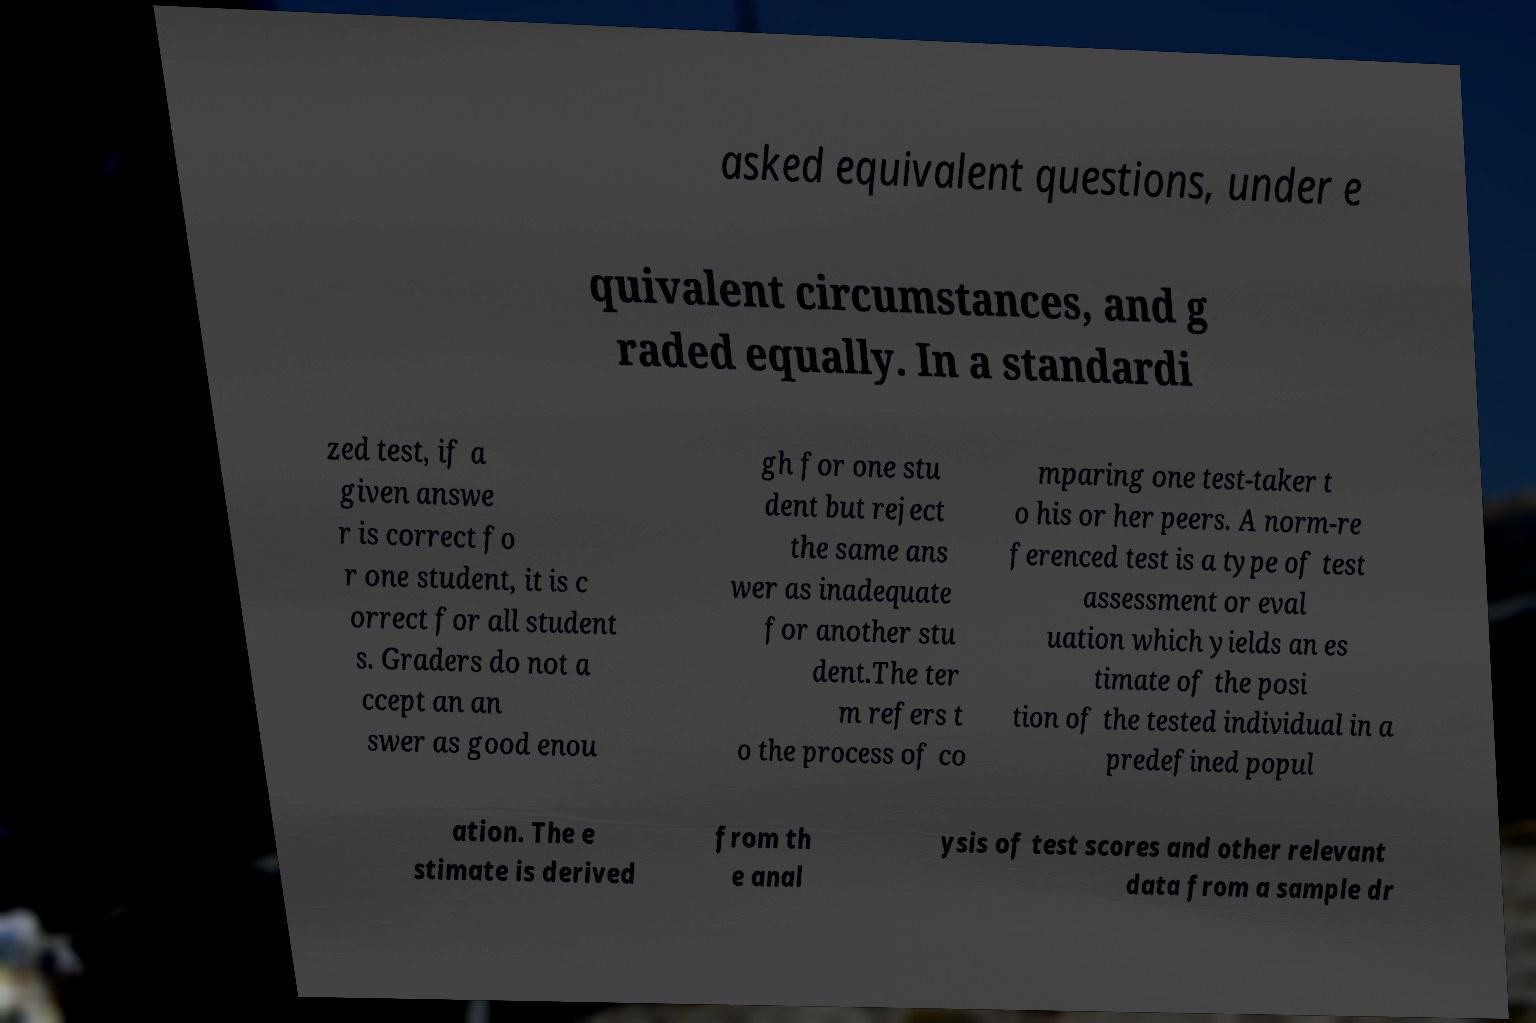Can you accurately transcribe the text from the provided image for me? asked equivalent questions, under e quivalent circumstances, and g raded equally. In a standardi zed test, if a given answe r is correct fo r one student, it is c orrect for all student s. Graders do not a ccept an an swer as good enou gh for one stu dent but reject the same ans wer as inadequate for another stu dent.The ter m refers t o the process of co mparing one test-taker t o his or her peers. A norm-re ferenced test is a type of test assessment or eval uation which yields an es timate of the posi tion of the tested individual in a predefined popul ation. The e stimate is derived from th e anal ysis of test scores and other relevant data from a sample dr 